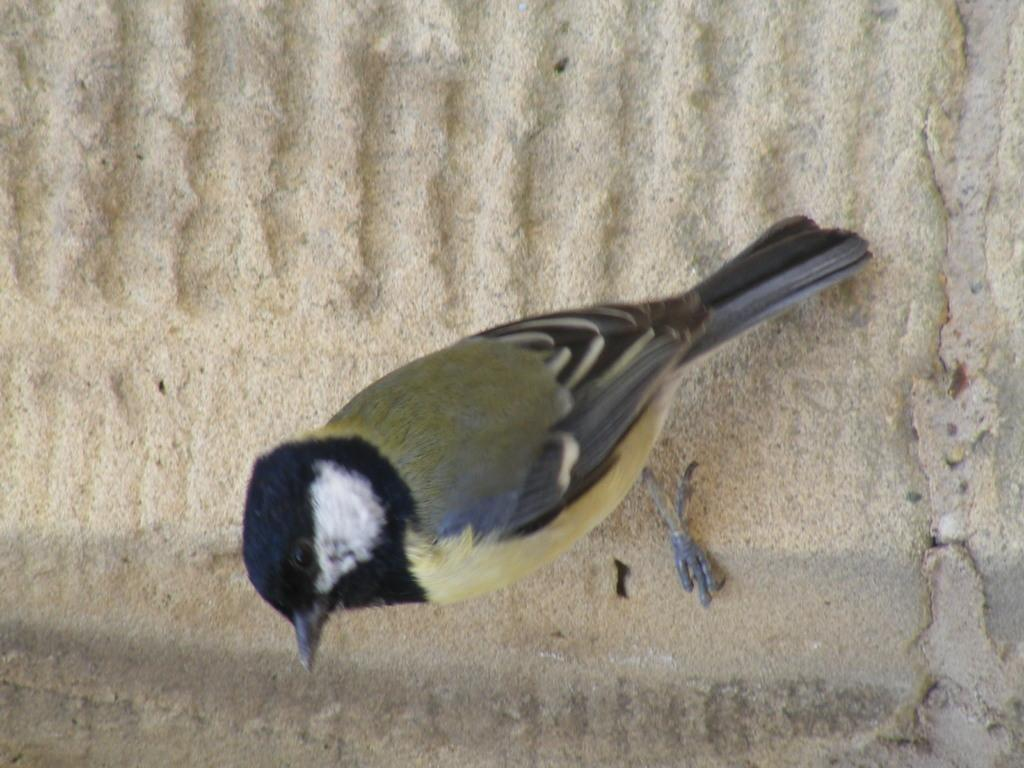What type of animal can be seen in the image? There is a bird in the image. Where is the bird located? The bird is on a wall. What degree does the bird have in the image? The bird does not have a degree in the image, as birds do not obtain degrees. 